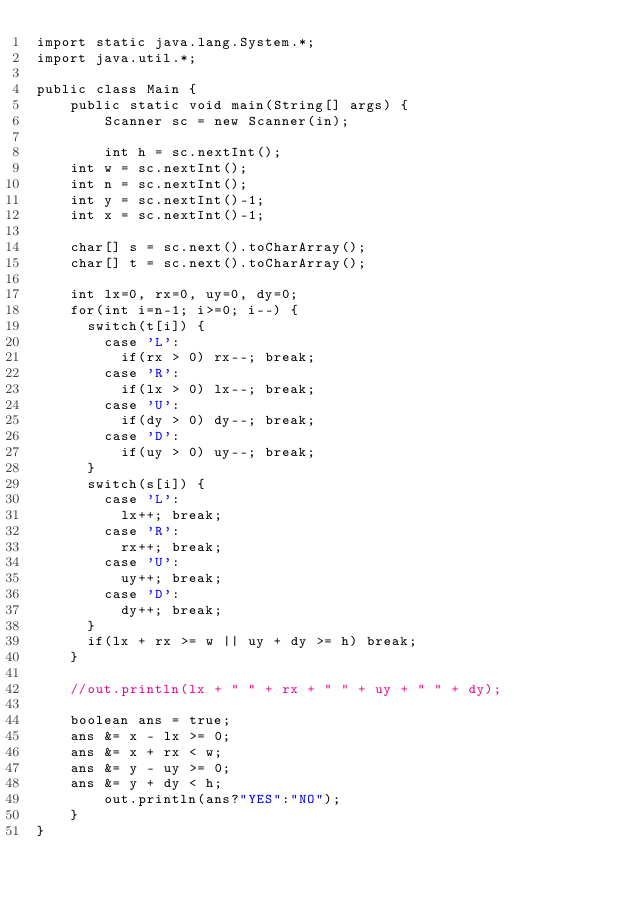<code> <loc_0><loc_0><loc_500><loc_500><_Java_>import static java.lang.System.*;
import java.util.*;

public class Main {
    public static void main(String[] args) {
        Scanner sc = new Scanner(in);

        int h = sc.nextInt();
		int w = sc.nextInt();
		int n = sc.nextInt();
		int y = sc.nextInt()-1;
		int x = sc.nextInt()-1;
		
		char[] s = sc.next().toCharArray();
		char[] t = sc.next().toCharArray();
		
		int lx=0, rx=0, uy=0, dy=0;
		for(int i=n-1; i>=0; i--) {
			switch(t[i]) {
				case 'L':
					if(rx > 0) rx--; break;
				case 'R':
					if(lx > 0) lx--; break;
				case 'U':
					if(dy > 0) dy--; break;
				case 'D':
					if(uy > 0) uy--; break;
			}
			switch(s[i]) {
				case 'L':
					lx++; break;
				case 'R':
					rx++; break;
				case 'U':
					uy++; break;
				case 'D':
					dy++; break;
			}
			if(lx + rx >= w || uy + dy >= h) break;
		}

		//out.println(lx + " " + rx + " " + uy + " " + dy);
		
		boolean ans = true;
		ans &= x - lx >= 0;
		ans &= x + rx < w;
		ans &= y - uy >= 0;
		ans &= y + dy < h;
        out.println(ans?"YES":"NO");
    }
}
</code> 